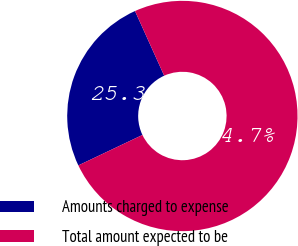<chart> <loc_0><loc_0><loc_500><loc_500><pie_chart><fcel>Amounts charged to expense<fcel>Total amount expected to be<nl><fcel>25.31%<fcel>74.69%<nl></chart> 